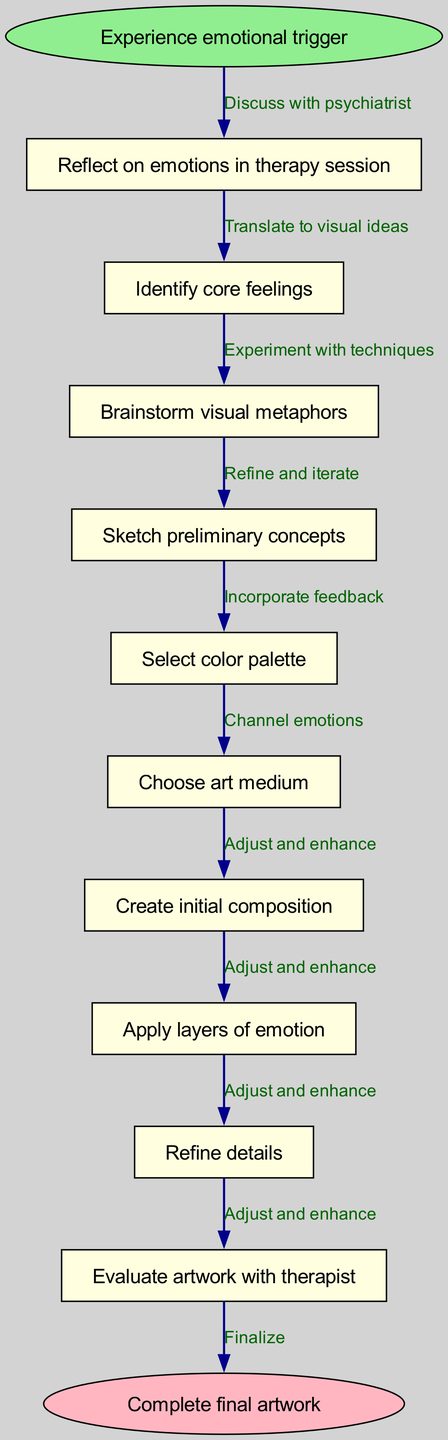What is the starting point of the process? The diagram indicates that the starting point of the process is labeled as "Experience emotional trigger."
Answer: Experience emotional trigger How many nodes are present in the diagram? The diagram contains a total of 11 nodes: 1 start node, 10 process nodes, and 1 end node.
Answer: 11 What is the last step before the final artwork? The last process step before reaching the final artwork is "Refine details."
Answer: Refine details Which node follows "Identify core feelings"? The diagram shows that the node following "Identify core feelings" is "Brainstorm visual metaphors."
Answer: Brainstorm visual metaphors What is the relationship between the start node and the first process node? The start node "Experience emotional trigger" connects directly to the first process node "Reflect on emotions in therapy session," with an edge that denotes the discussion with the psychiatrist.
Answer: Discuss with psychiatrist How many edges connect the nodes? There are a total of 10 edges connecting the nodes to represent the flow of the creative process.
Answer: 10 What is the final state of the creative process? The diagram concludes with the final state labeled as "Complete final artwork."
Answer: Complete final artwork What process step involves selecting colors? The process step that involves selecting colors is labeled as "Select color palette."
Answer: Select color palette Which node connects "Apply layers of emotion" to the next step? "Apply layers of emotion" connects to "Refine details," indicating a progression towards enhancing the artwork.
Answer: Refine details 